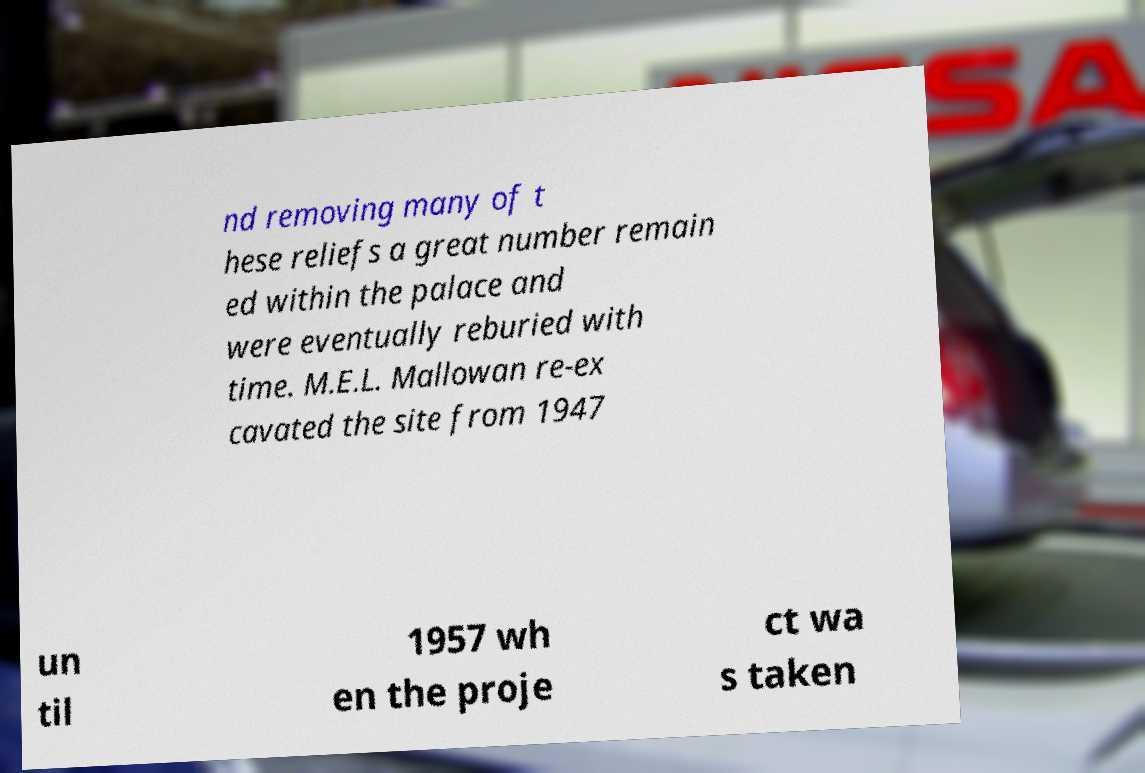What messages or text are displayed in this image? I need them in a readable, typed format. nd removing many of t hese reliefs a great number remain ed within the palace and were eventually reburied with time. M.E.L. Mallowan re-ex cavated the site from 1947 un til 1957 wh en the proje ct wa s taken 